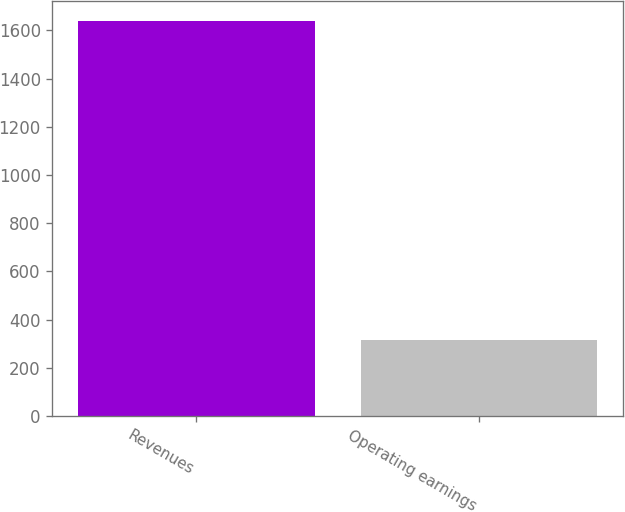Convert chart to OTSL. <chart><loc_0><loc_0><loc_500><loc_500><bar_chart><fcel>Revenues<fcel>Operating earnings<nl><fcel>1639<fcel>313<nl></chart> 